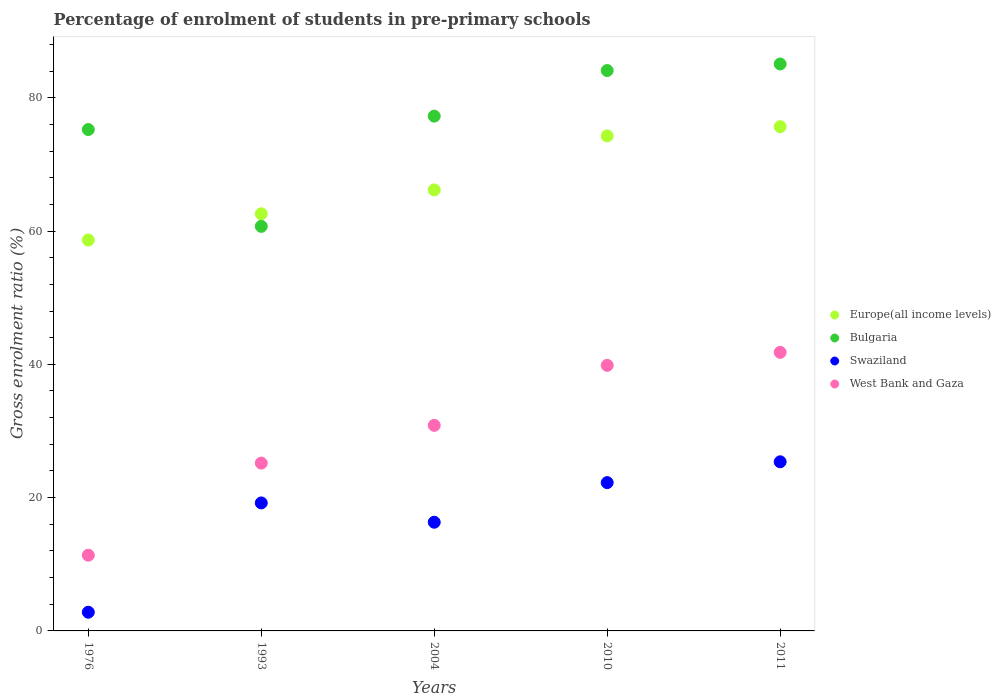How many different coloured dotlines are there?
Your answer should be compact. 4. What is the percentage of students enrolled in pre-primary schools in Swaziland in 1993?
Make the answer very short. 19.21. Across all years, what is the maximum percentage of students enrolled in pre-primary schools in Bulgaria?
Make the answer very short. 85.07. Across all years, what is the minimum percentage of students enrolled in pre-primary schools in West Bank and Gaza?
Ensure brevity in your answer.  11.36. In which year was the percentage of students enrolled in pre-primary schools in West Bank and Gaza maximum?
Your answer should be very brief. 2011. In which year was the percentage of students enrolled in pre-primary schools in West Bank and Gaza minimum?
Keep it short and to the point. 1976. What is the total percentage of students enrolled in pre-primary schools in Bulgaria in the graph?
Provide a succinct answer. 382.33. What is the difference between the percentage of students enrolled in pre-primary schools in Swaziland in 1993 and that in 2011?
Your answer should be compact. -6.17. What is the difference between the percentage of students enrolled in pre-primary schools in West Bank and Gaza in 2004 and the percentage of students enrolled in pre-primary schools in Swaziland in 1976?
Ensure brevity in your answer.  28.04. What is the average percentage of students enrolled in pre-primary schools in Bulgaria per year?
Keep it short and to the point. 76.47. In the year 1993, what is the difference between the percentage of students enrolled in pre-primary schools in Bulgaria and percentage of students enrolled in pre-primary schools in West Bank and Gaza?
Provide a short and direct response. 35.53. In how many years, is the percentage of students enrolled in pre-primary schools in Swaziland greater than 32 %?
Keep it short and to the point. 0. What is the ratio of the percentage of students enrolled in pre-primary schools in West Bank and Gaza in 1976 to that in 2010?
Give a very brief answer. 0.29. Is the difference between the percentage of students enrolled in pre-primary schools in Bulgaria in 1993 and 2010 greater than the difference between the percentage of students enrolled in pre-primary schools in West Bank and Gaza in 1993 and 2010?
Provide a short and direct response. No. What is the difference between the highest and the second highest percentage of students enrolled in pre-primary schools in West Bank and Gaza?
Offer a terse response. 1.95. What is the difference between the highest and the lowest percentage of students enrolled in pre-primary schools in Bulgaria?
Provide a succinct answer. 24.36. In how many years, is the percentage of students enrolled in pre-primary schools in Bulgaria greater than the average percentage of students enrolled in pre-primary schools in Bulgaria taken over all years?
Make the answer very short. 3. Is the sum of the percentage of students enrolled in pre-primary schools in Bulgaria in 1976 and 1993 greater than the maximum percentage of students enrolled in pre-primary schools in West Bank and Gaza across all years?
Provide a short and direct response. Yes. Is it the case that in every year, the sum of the percentage of students enrolled in pre-primary schools in Bulgaria and percentage of students enrolled in pre-primary schools in West Bank and Gaza  is greater than the percentage of students enrolled in pre-primary schools in Swaziland?
Your answer should be compact. Yes. Does the percentage of students enrolled in pre-primary schools in West Bank and Gaza monotonically increase over the years?
Your answer should be compact. Yes. Is the percentage of students enrolled in pre-primary schools in Swaziland strictly greater than the percentage of students enrolled in pre-primary schools in Bulgaria over the years?
Offer a terse response. No. Is the percentage of students enrolled in pre-primary schools in Bulgaria strictly less than the percentage of students enrolled in pre-primary schools in Swaziland over the years?
Your response must be concise. No. How many years are there in the graph?
Provide a succinct answer. 5. What is the difference between two consecutive major ticks on the Y-axis?
Give a very brief answer. 20. Are the values on the major ticks of Y-axis written in scientific E-notation?
Provide a succinct answer. No. Does the graph contain any zero values?
Give a very brief answer. No. Where does the legend appear in the graph?
Give a very brief answer. Center right. How many legend labels are there?
Provide a short and direct response. 4. What is the title of the graph?
Give a very brief answer. Percentage of enrolment of students in pre-primary schools. What is the label or title of the Y-axis?
Provide a succinct answer. Gross enrolment ratio (%). What is the Gross enrolment ratio (%) in Europe(all income levels) in 1976?
Offer a terse response. 58.65. What is the Gross enrolment ratio (%) in Bulgaria in 1976?
Ensure brevity in your answer.  75.23. What is the Gross enrolment ratio (%) of Swaziland in 1976?
Offer a very short reply. 2.81. What is the Gross enrolment ratio (%) in West Bank and Gaza in 1976?
Make the answer very short. 11.36. What is the Gross enrolment ratio (%) in Europe(all income levels) in 1993?
Offer a very short reply. 62.59. What is the Gross enrolment ratio (%) of Bulgaria in 1993?
Your answer should be compact. 60.7. What is the Gross enrolment ratio (%) in Swaziland in 1993?
Your answer should be compact. 19.21. What is the Gross enrolment ratio (%) in West Bank and Gaza in 1993?
Your answer should be compact. 25.18. What is the Gross enrolment ratio (%) of Europe(all income levels) in 2004?
Offer a very short reply. 66.17. What is the Gross enrolment ratio (%) in Bulgaria in 2004?
Provide a succinct answer. 77.24. What is the Gross enrolment ratio (%) in Swaziland in 2004?
Your answer should be compact. 16.31. What is the Gross enrolment ratio (%) of West Bank and Gaza in 2004?
Your response must be concise. 30.84. What is the Gross enrolment ratio (%) in Europe(all income levels) in 2010?
Provide a succinct answer. 74.28. What is the Gross enrolment ratio (%) of Bulgaria in 2010?
Your response must be concise. 84.08. What is the Gross enrolment ratio (%) in Swaziland in 2010?
Make the answer very short. 22.25. What is the Gross enrolment ratio (%) of West Bank and Gaza in 2010?
Provide a succinct answer. 39.85. What is the Gross enrolment ratio (%) of Europe(all income levels) in 2011?
Your answer should be compact. 75.66. What is the Gross enrolment ratio (%) in Bulgaria in 2011?
Make the answer very short. 85.07. What is the Gross enrolment ratio (%) in Swaziland in 2011?
Offer a very short reply. 25.38. What is the Gross enrolment ratio (%) in West Bank and Gaza in 2011?
Offer a terse response. 41.8. Across all years, what is the maximum Gross enrolment ratio (%) in Europe(all income levels)?
Ensure brevity in your answer.  75.66. Across all years, what is the maximum Gross enrolment ratio (%) in Bulgaria?
Ensure brevity in your answer.  85.07. Across all years, what is the maximum Gross enrolment ratio (%) of Swaziland?
Your answer should be very brief. 25.38. Across all years, what is the maximum Gross enrolment ratio (%) in West Bank and Gaza?
Provide a succinct answer. 41.8. Across all years, what is the minimum Gross enrolment ratio (%) in Europe(all income levels)?
Provide a succinct answer. 58.65. Across all years, what is the minimum Gross enrolment ratio (%) of Bulgaria?
Your answer should be very brief. 60.7. Across all years, what is the minimum Gross enrolment ratio (%) in Swaziland?
Offer a very short reply. 2.81. Across all years, what is the minimum Gross enrolment ratio (%) in West Bank and Gaza?
Offer a terse response. 11.36. What is the total Gross enrolment ratio (%) of Europe(all income levels) in the graph?
Provide a short and direct response. 337.35. What is the total Gross enrolment ratio (%) in Bulgaria in the graph?
Ensure brevity in your answer.  382.32. What is the total Gross enrolment ratio (%) of Swaziland in the graph?
Offer a very short reply. 85.95. What is the total Gross enrolment ratio (%) in West Bank and Gaza in the graph?
Provide a succinct answer. 149.03. What is the difference between the Gross enrolment ratio (%) in Europe(all income levels) in 1976 and that in 1993?
Ensure brevity in your answer.  -3.93. What is the difference between the Gross enrolment ratio (%) of Bulgaria in 1976 and that in 1993?
Offer a very short reply. 14.52. What is the difference between the Gross enrolment ratio (%) in Swaziland in 1976 and that in 1993?
Your answer should be very brief. -16.4. What is the difference between the Gross enrolment ratio (%) of West Bank and Gaza in 1976 and that in 1993?
Give a very brief answer. -13.82. What is the difference between the Gross enrolment ratio (%) of Europe(all income levels) in 1976 and that in 2004?
Give a very brief answer. -7.52. What is the difference between the Gross enrolment ratio (%) of Bulgaria in 1976 and that in 2004?
Keep it short and to the point. -2.01. What is the difference between the Gross enrolment ratio (%) of Swaziland in 1976 and that in 2004?
Give a very brief answer. -13.51. What is the difference between the Gross enrolment ratio (%) of West Bank and Gaza in 1976 and that in 2004?
Give a very brief answer. -19.48. What is the difference between the Gross enrolment ratio (%) of Europe(all income levels) in 1976 and that in 2010?
Provide a succinct answer. -15.62. What is the difference between the Gross enrolment ratio (%) in Bulgaria in 1976 and that in 2010?
Offer a very short reply. -8.85. What is the difference between the Gross enrolment ratio (%) of Swaziland in 1976 and that in 2010?
Offer a terse response. -19.45. What is the difference between the Gross enrolment ratio (%) of West Bank and Gaza in 1976 and that in 2010?
Provide a succinct answer. -28.49. What is the difference between the Gross enrolment ratio (%) of Europe(all income levels) in 1976 and that in 2011?
Keep it short and to the point. -17.01. What is the difference between the Gross enrolment ratio (%) in Bulgaria in 1976 and that in 2011?
Ensure brevity in your answer.  -9.84. What is the difference between the Gross enrolment ratio (%) of Swaziland in 1976 and that in 2011?
Give a very brief answer. -22.57. What is the difference between the Gross enrolment ratio (%) in West Bank and Gaza in 1976 and that in 2011?
Your response must be concise. -30.43. What is the difference between the Gross enrolment ratio (%) of Europe(all income levels) in 1993 and that in 2004?
Offer a very short reply. -3.59. What is the difference between the Gross enrolment ratio (%) of Bulgaria in 1993 and that in 2004?
Your answer should be compact. -16.54. What is the difference between the Gross enrolment ratio (%) of Swaziland in 1993 and that in 2004?
Make the answer very short. 2.9. What is the difference between the Gross enrolment ratio (%) of West Bank and Gaza in 1993 and that in 2004?
Your answer should be compact. -5.67. What is the difference between the Gross enrolment ratio (%) of Europe(all income levels) in 1993 and that in 2010?
Your response must be concise. -11.69. What is the difference between the Gross enrolment ratio (%) of Bulgaria in 1993 and that in 2010?
Provide a succinct answer. -23.38. What is the difference between the Gross enrolment ratio (%) in Swaziland in 1993 and that in 2010?
Your answer should be very brief. -3.05. What is the difference between the Gross enrolment ratio (%) of West Bank and Gaza in 1993 and that in 2010?
Offer a terse response. -14.67. What is the difference between the Gross enrolment ratio (%) of Europe(all income levels) in 1993 and that in 2011?
Your response must be concise. -13.07. What is the difference between the Gross enrolment ratio (%) in Bulgaria in 1993 and that in 2011?
Provide a short and direct response. -24.36. What is the difference between the Gross enrolment ratio (%) of Swaziland in 1993 and that in 2011?
Make the answer very short. -6.17. What is the difference between the Gross enrolment ratio (%) of West Bank and Gaza in 1993 and that in 2011?
Keep it short and to the point. -16.62. What is the difference between the Gross enrolment ratio (%) in Europe(all income levels) in 2004 and that in 2010?
Your answer should be very brief. -8.1. What is the difference between the Gross enrolment ratio (%) in Bulgaria in 2004 and that in 2010?
Ensure brevity in your answer.  -6.84. What is the difference between the Gross enrolment ratio (%) of Swaziland in 2004 and that in 2010?
Your answer should be very brief. -5.94. What is the difference between the Gross enrolment ratio (%) of West Bank and Gaza in 2004 and that in 2010?
Provide a succinct answer. -9. What is the difference between the Gross enrolment ratio (%) of Europe(all income levels) in 2004 and that in 2011?
Ensure brevity in your answer.  -9.49. What is the difference between the Gross enrolment ratio (%) of Bulgaria in 2004 and that in 2011?
Make the answer very short. -7.82. What is the difference between the Gross enrolment ratio (%) in Swaziland in 2004 and that in 2011?
Provide a succinct answer. -9.06. What is the difference between the Gross enrolment ratio (%) of West Bank and Gaza in 2004 and that in 2011?
Provide a short and direct response. -10.95. What is the difference between the Gross enrolment ratio (%) of Europe(all income levels) in 2010 and that in 2011?
Your answer should be compact. -1.38. What is the difference between the Gross enrolment ratio (%) in Bulgaria in 2010 and that in 2011?
Your response must be concise. -0.98. What is the difference between the Gross enrolment ratio (%) in Swaziland in 2010 and that in 2011?
Offer a terse response. -3.12. What is the difference between the Gross enrolment ratio (%) of West Bank and Gaza in 2010 and that in 2011?
Offer a very short reply. -1.95. What is the difference between the Gross enrolment ratio (%) in Europe(all income levels) in 1976 and the Gross enrolment ratio (%) in Bulgaria in 1993?
Offer a terse response. -2.05. What is the difference between the Gross enrolment ratio (%) of Europe(all income levels) in 1976 and the Gross enrolment ratio (%) of Swaziland in 1993?
Make the answer very short. 39.45. What is the difference between the Gross enrolment ratio (%) of Europe(all income levels) in 1976 and the Gross enrolment ratio (%) of West Bank and Gaza in 1993?
Give a very brief answer. 33.47. What is the difference between the Gross enrolment ratio (%) of Bulgaria in 1976 and the Gross enrolment ratio (%) of Swaziland in 1993?
Your response must be concise. 56.02. What is the difference between the Gross enrolment ratio (%) in Bulgaria in 1976 and the Gross enrolment ratio (%) in West Bank and Gaza in 1993?
Offer a terse response. 50.05. What is the difference between the Gross enrolment ratio (%) of Swaziland in 1976 and the Gross enrolment ratio (%) of West Bank and Gaza in 1993?
Make the answer very short. -22.37. What is the difference between the Gross enrolment ratio (%) of Europe(all income levels) in 1976 and the Gross enrolment ratio (%) of Bulgaria in 2004?
Provide a short and direct response. -18.59. What is the difference between the Gross enrolment ratio (%) in Europe(all income levels) in 1976 and the Gross enrolment ratio (%) in Swaziland in 2004?
Provide a short and direct response. 42.34. What is the difference between the Gross enrolment ratio (%) of Europe(all income levels) in 1976 and the Gross enrolment ratio (%) of West Bank and Gaza in 2004?
Make the answer very short. 27.81. What is the difference between the Gross enrolment ratio (%) of Bulgaria in 1976 and the Gross enrolment ratio (%) of Swaziland in 2004?
Ensure brevity in your answer.  58.92. What is the difference between the Gross enrolment ratio (%) in Bulgaria in 1976 and the Gross enrolment ratio (%) in West Bank and Gaza in 2004?
Provide a short and direct response. 44.38. What is the difference between the Gross enrolment ratio (%) of Swaziland in 1976 and the Gross enrolment ratio (%) of West Bank and Gaza in 2004?
Ensure brevity in your answer.  -28.04. What is the difference between the Gross enrolment ratio (%) of Europe(all income levels) in 1976 and the Gross enrolment ratio (%) of Bulgaria in 2010?
Give a very brief answer. -25.43. What is the difference between the Gross enrolment ratio (%) of Europe(all income levels) in 1976 and the Gross enrolment ratio (%) of Swaziland in 2010?
Provide a succinct answer. 36.4. What is the difference between the Gross enrolment ratio (%) of Europe(all income levels) in 1976 and the Gross enrolment ratio (%) of West Bank and Gaza in 2010?
Provide a succinct answer. 18.81. What is the difference between the Gross enrolment ratio (%) in Bulgaria in 1976 and the Gross enrolment ratio (%) in Swaziland in 2010?
Make the answer very short. 52.98. What is the difference between the Gross enrolment ratio (%) in Bulgaria in 1976 and the Gross enrolment ratio (%) in West Bank and Gaza in 2010?
Offer a very short reply. 35.38. What is the difference between the Gross enrolment ratio (%) of Swaziland in 1976 and the Gross enrolment ratio (%) of West Bank and Gaza in 2010?
Offer a terse response. -37.04. What is the difference between the Gross enrolment ratio (%) in Europe(all income levels) in 1976 and the Gross enrolment ratio (%) in Bulgaria in 2011?
Offer a terse response. -26.41. What is the difference between the Gross enrolment ratio (%) in Europe(all income levels) in 1976 and the Gross enrolment ratio (%) in Swaziland in 2011?
Ensure brevity in your answer.  33.28. What is the difference between the Gross enrolment ratio (%) in Europe(all income levels) in 1976 and the Gross enrolment ratio (%) in West Bank and Gaza in 2011?
Offer a terse response. 16.86. What is the difference between the Gross enrolment ratio (%) in Bulgaria in 1976 and the Gross enrolment ratio (%) in Swaziland in 2011?
Offer a terse response. 49.85. What is the difference between the Gross enrolment ratio (%) in Bulgaria in 1976 and the Gross enrolment ratio (%) in West Bank and Gaza in 2011?
Ensure brevity in your answer.  33.43. What is the difference between the Gross enrolment ratio (%) in Swaziland in 1976 and the Gross enrolment ratio (%) in West Bank and Gaza in 2011?
Provide a succinct answer. -38.99. What is the difference between the Gross enrolment ratio (%) of Europe(all income levels) in 1993 and the Gross enrolment ratio (%) of Bulgaria in 2004?
Offer a terse response. -14.65. What is the difference between the Gross enrolment ratio (%) in Europe(all income levels) in 1993 and the Gross enrolment ratio (%) in Swaziland in 2004?
Keep it short and to the point. 46.28. What is the difference between the Gross enrolment ratio (%) in Europe(all income levels) in 1993 and the Gross enrolment ratio (%) in West Bank and Gaza in 2004?
Provide a short and direct response. 31.74. What is the difference between the Gross enrolment ratio (%) in Bulgaria in 1993 and the Gross enrolment ratio (%) in Swaziland in 2004?
Offer a terse response. 44.39. What is the difference between the Gross enrolment ratio (%) in Bulgaria in 1993 and the Gross enrolment ratio (%) in West Bank and Gaza in 2004?
Give a very brief answer. 29.86. What is the difference between the Gross enrolment ratio (%) in Swaziland in 1993 and the Gross enrolment ratio (%) in West Bank and Gaza in 2004?
Your response must be concise. -11.64. What is the difference between the Gross enrolment ratio (%) in Europe(all income levels) in 1993 and the Gross enrolment ratio (%) in Bulgaria in 2010?
Offer a very short reply. -21.5. What is the difference between the Gross enrolment ratio (%) in Europe(all income levels) in 1993 and the Gross enrolment ratio (%) in Swaziland in 2010?
Your answer should be compact. 40.34. What is the difference between the Gross enrolment ratio (%) of Europe(all income levels) in 1993 and the Gross enrolment ratio (%) of West Bank and Gaza in 2010?
Offer a very short reply. 22.74. What is the difference between the Gross enrolment ratio (%) in Bulgaria in 1993 and the Gross enrolment ratio (%) in Swaziland in 2010?
Your answer should be very brief. 38.45. What is the difference between the Gross enrolment ratio (%) of Bulgaria in 1993 and the Gross enrolment ratio (%) of West Bank and Gaza in 2010?
Keep it short and to the point. 20.86. What is the difference between the Gross enrolment ratio (%) of Swaziland in 1993 and the Gross enrolment ratio (%) of West Bank and Gaza in 2010?
Offer a very short reply. -20.64. What is the difference between the Gross enrolment ratio (%) of Europe(all income levels) in 1993 and the Gross enrolment ratio (%) of Bulgaria in 2011?
Your response must be concise. -22.48. What is the difference between the Gross enrolment ratio (%) of Europe(all income levels) in 1993 and the Gross enrolment ratio (%) of Swaziland in 2011?
Offer a very short reply. 37.21. What is the difference between the Gross enrolment ratio (%) in Europe(all income levels) in 1993 and the Gross enrolment ratio (%) in West Bank and Gaza in 2011?
Keep it short and to the point. 20.79. What is the difference between the Gross enrolment ratio (%) in Bulgaria in 1993 and the Gross enrolment ratio (%) in Swaziland in 2011?
Your response must be concise. 35.33. What is the difference between the Gross enrolment ratio (%) in Bulgaria in 1993 and the Gross enrolment ratio (%) in West Bank and Gaza in 2011?
Ensure brevity in your answer.  18.91. What is the difference between the Gross enrolment ratio (%) in Swaziland in 1993 and the Gross enrolment ratio (%) in West Bank and Gaza in 2011?
Your answer should be compact. -22.59. What is the difference between the Gross enrolment ratio (%) of Europe(all income levels) in 2004 and the Gross enrolment ratio (%) of Bulgaria in 2010?
Ensure brevity in your answer.  -17.91. What is the difference between the Gross enrolment ratio (%) of Europe(all income levels) in 2004 and the Gross enrolment ratio (%) of Swaziland in 2010?
Your answer should be compact. 43.92. What is the difference between the Gross enrolment ratio (%) in Europe(all income levels) in 2004 and the Gross enrolment ratio (%) in West Bank and Gaza in 2010?
Make the answer very short. 26.33. What is the difference between the Gross enrolment ratio (%) in Bulgaria in 2004 and the Gross enrolment ratio (%) in Swaziland in 2010?
Offer a terse response. 54.99. What is the difference between the Gross enrolment ratio (%) in Bulgaria in 2004 and the Gross enrolment ratio (%) in West Bank and Gaza in 2010?
Your response must be concise. 37.39. What is the difference between the Gross enrolment ratio (%) of Swaziland in 2004 and the Gross enrolment ratio (%) of West Bank and Gaza in 2010?
Provide a short and direct response. -23.54. What is the difference between the Gross enrolment ratio (%) in Europe(all income levels) in 2004 and the Gross enrolment ratio (%) in Bulgaria in 2011?
Your answer should be very brief. -18.89. What is the difference between the Gross enrolment ratio (%) of Europe(all income levels) in 2004 and the Gross enrolment ratio (%) of Swaziland in 2011?
Make the answer very short. 40.8. What is the difference between the Gross enrolment ratio (%) of Europe(all income levels) in 2004 and the Gross enrolment ratio (%) of West Bank and Gaza in 2011?
Offer a very short reply. 24.38. What is the difference between the Gross enrolment ratio (%) in Bulgaria in 2004 and the Gross enrolment ratio (%) in Swaziland in 2011?
Your answer should be compact. 51.87. What is the difference between the Gross enrolment ratio (%) of Bulgaria in 2004 and the Gross enrolment ratio (%) of West Bank and Gaza in 2011?
Your response must be concise. 35.44. What is the difference between the Gross enrolment ratio (%) in Swaziland in 2004 and the Gross enrolment ratio (%) in West Bank and Gaza in 2011?
Give a very brief answer. -25.49. What is the difference between the Gross enrolment ratio (%) of Europe(all income levels) in 2010 and the Gross enrolment ratio (%) of Bulgaria in 2011?
Your answer should be compact. -10.79. What is the difference between the Gross enrolment ratio (%) of Europe(all income levels) in 2010 and the Gross enrolment ratio (%) of Swaziland in 2011?
Ensure brevity in your answer.  48.9. What is the difference between the Gross enrolment ratio (%) in Europe(all income levels) in 2010 and the Gross enrolment ratio (%) in West Bank and Gaza in 2011?
Make the answer very short. 32.48. What is the difference between the Gross enrolment ratio (%) in Bulgaria in 2010 and the Gross enrolment ratio (%) in Swaziland in 2011?
Offer a terse response. 58.71. What is the difference between the Gross enrolment ratio (%) in Bulgaria in 2010 and the Gross enrolment ratio (%) in West Bank and Gaza in 2011?
Offer a very short reply. 42.29. What is the difference between the Gross enrolment ratio (%) of Swaziland in 2010 and the Gross enrolment ratio (%) of West Bank and Gaza in 2011?
Provide a succinct answer. -19.55. What is the average Gross enrolment ratio (%) in Europe(all income levels) per year?
Make the answer very short. 67.47. What is the average Gross enrolment ratio (%) of Bulgaria per year?
Keep it short and to the point. 76.47. What is the average Gross enrolment ratio (%) in Swaziland per year?
Make the answer very short. 17.19. What is the average Gross enrolment ratio (%) in West Bank and Gaza per year?
Give a very brief answer. 29.81. In the year 1976, what is the difference between the Gross enrolment ratio (%) in Europe(all income levels) and Gross enrolment ratio (%) in Bulgaria?
Your response must be concise. -16.58. In the year 1976, what is the difference between the Gross enrolment ratio (%) of Europe(all income levels) and Gross enrolment ratio (%) of Swaziland?
Ensure brevity in your answer.  55.85. In the year 1976, what is the difference between the Gross enrolment ratio (%) of Europe(all income levels) and Gross enrolment ratio (%) of West Bank and Gaza?
Offer a very short reply. 47.29. In the year 1976, what is the difference between the Gross enrolment ratio (%) of Bulgaria and Gross enrolment ratio (%) of Swaziland?
Make the answer very short. 72.42. In the year 1976, what is the difference between the Gross enrolment ratio (%) in Bulgaria and Gross enrolment ratio (%) in West Bank and Gaza?
Give a very brief answer. 63.87. In the year 1976, what is the difference between the Gross enrolment ratio (%) in Swaziland and Gross enrolment ratio (%) in West Bank and Gaza?
Keep it short and to the point. -8.56. In the year 1993, what is the difference between the Gross enrolment ratio (%) of Europe(all income levels) and Gross enrolment ratio (%) of Bulgaria?
Your answer should be very brief. 1.88. In the year 1993, what is the difference between the Gross enrolment ratio (%) in Europe(all income levels) and Gross enrolment ratio (%) in Swaziland?
Offer a terse response. 43.38. In the year 1993, what is the difference between the Gross enrolment ratio (%) in Europe(all income levels) and Gross enrolment ratio (%) in West Bank and Gaza?
Your response must be concise. 37.41. In the year 1993, what is the difference between the Gross enrolment ratio (%) of Bulgaria and Gross enrolment ratio (%) of Swaziland?
Provide a succinct answer. 41.5. In the year 1993, what is the difference between the Gross enrolment ratio (%) in Bulgaria and Gross enrolment ratio (%) in West Bank and Gaza?
Your answer should be compact. 35.53. In the year 1993, what is the difference between the Gross enrolment ratio (%) in Swaziland and Gross enrolment ratio (%) in West Bank and Gaza?
Your response must be concise. -5.97. In the year 2004, what is the difference between the Gross enrolment ratio (%) of Europe(all income levels) and Gross enrolment ratio (%) of Bulgaria?
Your response must be concise. -11.07. In the year 2004, what is the difference between the Gross enrolment ratio (%) of Europe(all income levels) and Gross enrolment ratio (%) of Swaziland?
Your response must be concise. 49.86. In the year 2004, what is the difference between the Gross enrolment ratio (%) in Europe(all income levels) and Gross enrolment ratio (%) in West Bank and Gaza?
Give a very brief answer. 35.33. In the year 2004, what is the difference between the Gross enrolment ratio (%) in Bulgaria and Gross enrolment ratio (%) in Swaziland?
Keep it short and to the point. 60.93. In the year 2004, what is the difference between the Gross enrolment ratio (%) in Bulgaria and Gross enrolment ratio (%) in West Bank and Gaza?
Ensure brevity in your answer.  46.4. In the year 2004, what is the difference between the Gross enrolment ratio (%) in Swaziland and Gross enrolment ratio (%) in West Bank and Gaza?
Offer a terse response. -14.53. In the year 2010, what is the difference between the Gross enrolment ratio (%) in Europe(all income levels) and Gross enrolment ratio (%) in Bulgaria?
Ensure brevity in your answer.  -9.81. In the year 2010, what is the difference between the Gross enrolment ratio (%) of Europe(all income levels) and Gross enrolment ratio (%) of Swaziland?
Provide a succinct answer. 52.03. In the year 2010, what is the difference between the Gross enrolment ratio (%) in Europe(all income levels) and Gross enrolment ratio (%) in West Bank and Gaza?
Ensure brevity in your answer.  34.43. In the year 2010, what is the difference between the Gross enrolment ratio (%) in Bulgaria and Gross enrolment ratio (%) in Swaziland?
Keep it short and to the point. 61.83. In the year 2010, what is the difference between the Gross enrolment ratio (%) in Bulgaria and Gross enrolment ratio (%) in West Bank and Gaza?
Your answer should be compact. 44.24. In the year 2010, what is the difference between the Gross enrolment ratio (%) in Swaziland and Gross enrolment ratio (%) in West Bank and Gaza?
Offer a very short reply. -17.6. In the year 2011, what is the difference between the Gross enrolment ratio (%) in Europe(all income levels) and Gross enrolment ratio (%) in Bulgaria?
Offer a terse response. -9.41. In the year 2011, what is the difference between the Gross enrolment ratio (%) in Europe(all income levels) and Gross enrolment ratio (%) in Swaziland?
Keep it short and to the point. 50.28. In the year 2011, what is the difference between the Gross enrolment ratio (%) of Europe(all income levels) and Gross enrolment ratio (%) of West Bank and Gaza?
Give a very brief answer. 33.86. In the year 2011, what is the difference between the Gross enrolment ratio (%) in Bulgaria and Gross enrolment ratio (%) in Swaziland?
Provide a short and direct response. 59.69. In the year 2011, what is the difference between the Gross enrolment ratio (%) in Bulgaria and Gross enrolment ratio (%) in West Bank and Gaza?
Your answer should be very brief. 43.27. In the year 2011, what is the difference between the Gross enrolment ratio (%) of Swaziland and Gross enrolment ratio (%) of West Bank and Gaza?
Give a very brief answer. -16.42. What is the ratio of the Gross enrolment ratio (%) in Europe(all income levels) in 1976 to that in 1993?
Make the answer very short. 0.94. What is the ratio of the Gross enrolment ratio (%) in Bulgaria in 1976 to that in 1993?
Your answer should be very brief. 1.24. What is the ratio of the Gross enrolment ratio (%) of Swaziland in 1976 to that in 1993?
Your response must be concise. 0.15. What is the ratio of the Gross enrolment ratio (%) of West Bank and Gaza in 1976 to that in 1993?
Your response must be concise. 0.45. What is the ratio of the Gross enrolment ratio (%) of Europe(all income levels) in 1976 to that in 2004?
Make the answer very short. 0.89. What is the ratio of the Gross enrolment ratio (%) in Bulgaria in 1976 to that in 2004?
Offer a terse response. 0.97. What is the ratio of the Gross enrolment ratio (%) in Swaziland in 1976 to that in 2004?
Your response must be concise. 0.17. What is the ratio of the Gross enrolment ratio (%) of West Bank and Gaza in 1976 to that in 2004?
Keep it short and to the point. 0.37. What is the ratio of the Gross enrolment ratio (%) of Europe(all income levels) in 1976 to that in 2010?
Provide a succinct answer. 0.79. What is the ratio of the Gross enrolment ratio (%) in Bulgaria in 1976 to that in 2010?
Your answer should be compact. 0.89. What is the ratio of the Gross enrolment ratio (%) of Swaziland in 1976 to that in 2010?
Give a very brief answer. 0.13. What is the ratio of the Gross enrolment ratio (%) in West Bank and Gaza in 1976 to that in 2010?
Make the answer very short. 0.29. What is the ratio of the Gross enrolment ratio (%) in Europe(all income levels) in 1976 to that in 2011?
Make the answer very short. 0.78. What is the ratio of the Gross enrolment ratio (%) of Bulgaria in 1976 to that in 2011?
Make the answer very short. 0.88. What is the ratio of the Gross enrolment ratio (%) in Swaziland in 1976 to that in 2011?
Offer a terse response. 0.11. What is the ratio of the Gross enrolment ratio (%) of West Bank and Gaza in 1976 to that in 2011?
Provide a short and direct response. 0.27. What is the ratio of the Gross enrolment ratio (%) in Europe(all income levels) in 1993 to that in 2004?
Offer a very short reply. 0.95. What is the ratio of the Gross enrolment ratio (%) of Bulgaria in 1993 to that in 2004?
Make the answer very short. 0.79. What is the ratio of the Gross enrolment ratio (%) of Swaziland in 1993 to that in 2004?
Provide a succinct answer. 1.18. What is the ratio of the Gross enrolment ratio (%) in West Bank and Gaza in 1993 to that in 2004?
Offer a terse response. 0.82. What is the ratio of the Gross enrolment ratio (%) of Europe(all income levels) in 1993 to that in 2010?
Your answer should be very brief. 0.84. What is the ratio of the Gross enrolment ratio (%) of Bulgaria in 1993 to that in 2010?
Offer a very short reply. 0.72. What is the ratio of the Gross enrolment ratio (%) in Swaziland in 1993 to that in 2010?
Offer a very short reply. 0.86. What is the ratio of the Gross enrolment ratio (%) of West Bank and Gaza in 1993 to that in 2010?
Ensure brevity in your answer.  0.63. What is the ratio of the Gross enrolment ratio (%) of Europe(all income levels) in 1993 to that in 2011?
Your answer should be very brief. 0.83. What is the ratio of the Gross enrolment ratio (%) in Bulgaria in 1993 to that in 2011?
Provide a short and direct response. 0.71. What is the ratio of the Gross enrolment ratio (%) of Swaziland in 1993 to that in 2011?
Provide a short and direct response. 0.76. What is the ratio of the Gross enrolment ratio (%) in West Bank and Gaza in 1993 to that in 2011?
Provide a succinct answer. 0.6. What is the ratio of the Gross enrolment ratio (%) of Europe(all income levels) in 2004 to that in 2010?
Provide a short and direct response. 0.89. What is the ratio of the Gross enrolment ratio (%) of Bulgaria in 2004 to that in 2010?
Ensure brevity in your answer.  0.92. What is the ratio of the Gross enrolment ratio (%) in Swaziland in 2004 to that in 2010?
Provide a short and direct response. 0.73. What is the ratio of the Gross enrolment ratio (%) of West Bank and Gaza in 2004 to that in 2010?
Ensure brevity in your answer.  0.77. What is the ratio of the Gross enrolment ratio (%) in Europe(all income levels) in 2004 to that in 2011?
Make the answer very short. 0.87. What is the ratio of the Gross enrolment ratio (%) of Bulgaria in 2004 to that in 2011?
Make the answer very short. 0.91. What is the ratio of the Gross enrolment ratio (%) in Swaziland in 2004 to that in 2011?
Make the answer very short. 0.64. What is the ratio of the Gross enrolment ratio (%) in West Bank and Gaza in 2004 to that in 2011?
Offer a terse response. 0.74. What is the ratio of the Gross enrolment ratio (%) of Europe(all income levels) in 2010 to that in 2011?
Make the answer very short. 0.98. What is the ratio of the Gross enrolment ratio (%) in Bulgaria in 2010 to that in 2011?
Your answer should be very brief. 0.99. What is the ratio of the Gross enrolment ratio (%) in Swaziland in 2010 to that in 2011?
Provide a short and direct response. 0.88. What is the ratio of the Gross enrolment ratio (%) of West Bank and Gaza in 2010 to that in 2011?
Provide a short and direct response. 0.95. What is the difference between the highest and the second highest Gross enrolment ratio (%) in Europe(all income levels)?
Offer a very short reply. 1.38. What is the difference between the highest and the second highest Gross enrolment ratio (%) of Bulgaria?
Give a very brief answer. 0.98. What is the difference between the highest and the second highest Gross enrolment ratio (%) of Swaziland?
Provide a succinct answer. 3.12. What is the difference between the highest and the second highest Gross enrolment ratio (%) in West Bank and Gaza?
Keep it short and to the point. 1.95. What is the difference between the highest and the lowest Gross enrolment ratio (%) in Europe(all income levels)?
Ensure brevity in your answer.  17.01. What is the difference between the highest and the lowest Gross enrolment ratio (%) in Bulgaria?
Ensure brevity in your answer.  24.36. What is the difference between the highest and the lowest Gross enrolment ratio (%) of Swaziland?
Offer a terse response. 22.57. What is the difference between the highest and the lowest Gross enrolment ratio (%) of West Bank and Gaza?
Your answer should be compact. 30.43. 